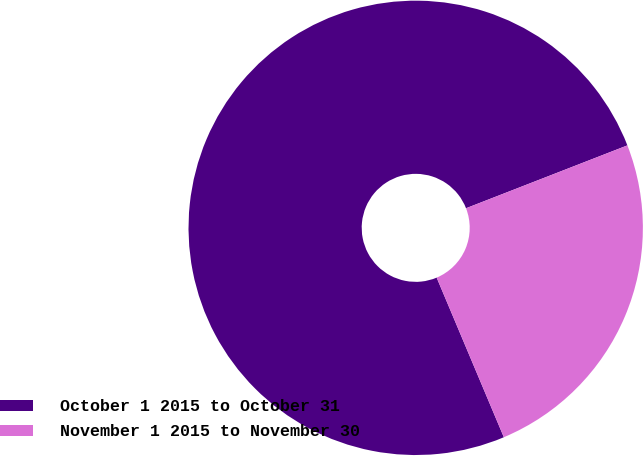Convert chart to OTSL. <chart><loc_0><loc_0><loc_500><loc_500><pie_chart><fcel>October 1 2015 to October 31<fcel>November 1 2015 to November 30<nl><fcel>75.43%<fcel>24.57%<nl></chart> 